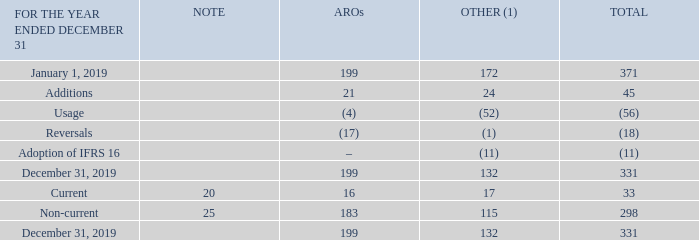Note 23 Provisions
(1) Other includes environmental, vacant space and legal provisions
AROs reflect management’s best estimates of expected future costs to restore current leased premises to their original condition prior to lease inception. Cash outflows associated with our ARO liabilities are generally expected to occur at the restoration dates of the assets to which they relate, which are long-term in nature. The timing and extent of restoration work that will be ultimately required for these sites is uncertain.
What does 'Other' include? Environmental, vacant space and legal provisions. What do the AROs reflect? Management’s best estimates of expected future costs to restore current leased premises to their original condition prior to lease inception. What are the types of provisions within the table?  Aros, other. How many components of provisions are accounted for? Additions##Usage##Reversals##Adoption of IFRS 16
Answer: 4. What is the difference in the amount of non-current provisions between AROs and Other? 183-115
Answer: 68. What is the ratio of non-current provisions for AROs over that of Other? 183/115
Answer: 1.59. 